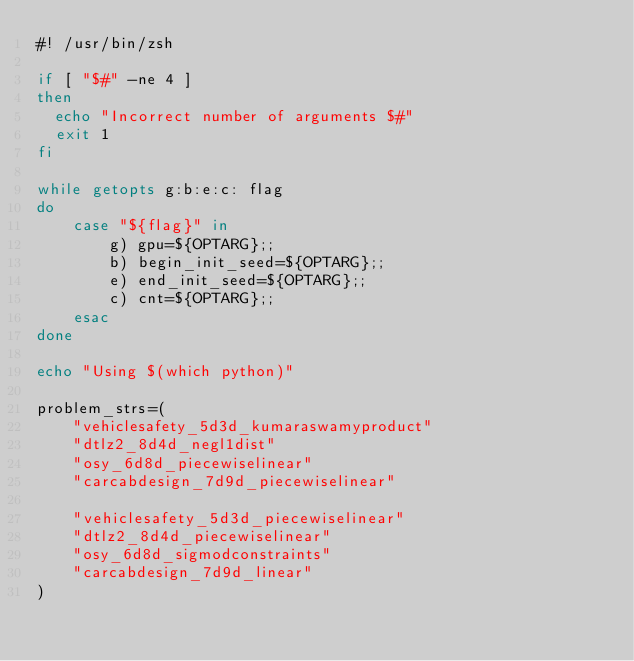<code> <loc_0><loc_0><loc_500><loc_500><_Bash_>#! /usr/bin/zsh

if [ "$#" -ne 4 ]
then
  echo "Incorrect number of arguments $#"
  exit 1
fi

while getopts g:b:e:c: flag
do
    case "${flag}" in
        g) gpu=${OPTARG};;
        b) begin_init_seed=${OPTARG};;
        e) end_init_seed=${OPTARG};;
        c) cnt=${OPTARG};;
    esac
done

echo "Using $(which python)"

problem_strs=(
    "vehiclesafety_5d3d_kumaraswamyproduct"
    "dtlz2_8d4d_negl1dist"
    "osy_6d8d_piecewiselinear"
    "carcabdesign_7d9d_piecewiselinear"

    "vehiclesafety_5d3d_piecewiselinear"
    "dtlz2_8d4d_piecewiselinear"
    "osy_6d8d_sigmodconstraints"
    "carcabdesign_7d9d_linear"
)
</code> 